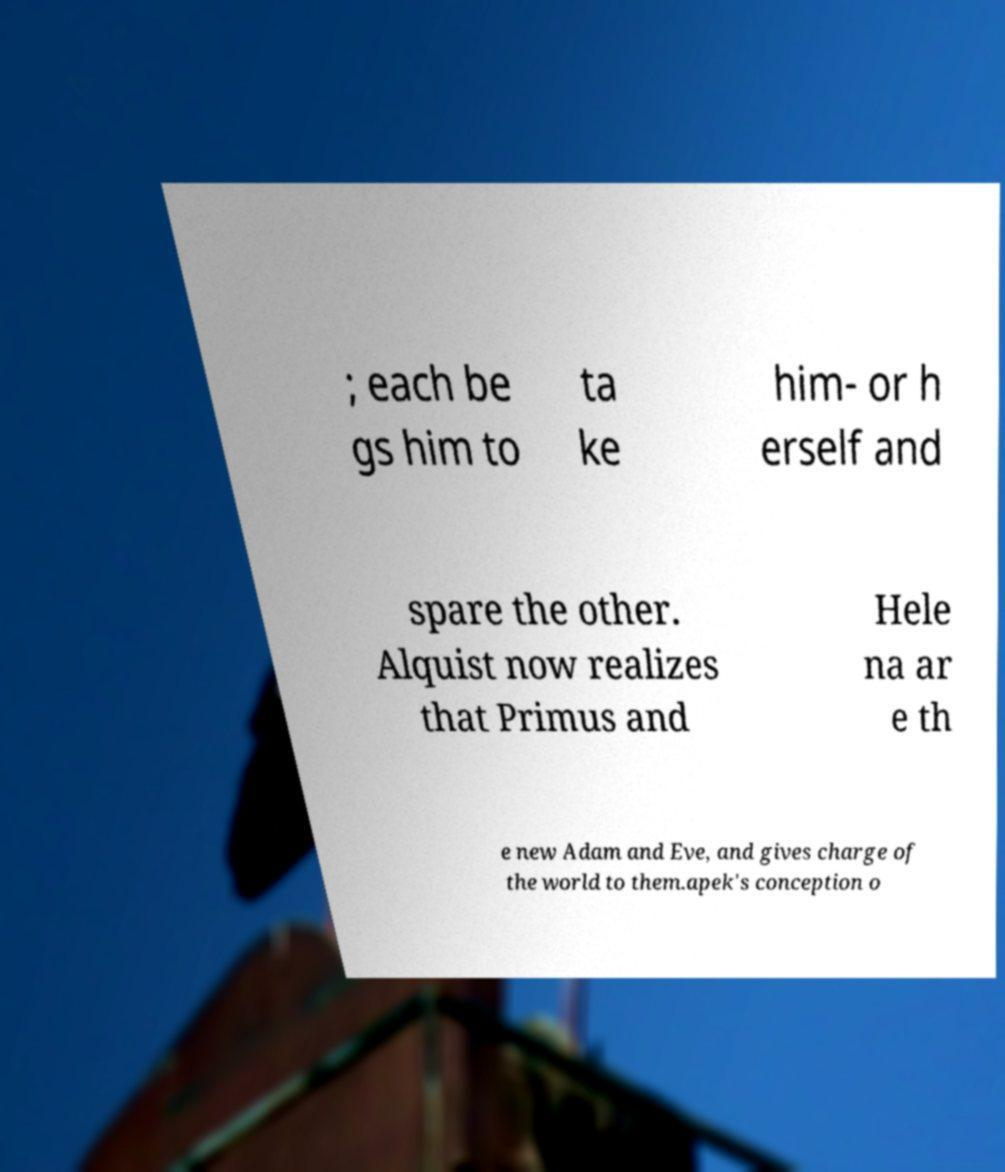Please identify and transcribe the text found in this image. ; each be gs him to ta ke him- or h erself and spare the other. Alquist now realizes that Primus and Hele na ar e th e new Adam and Eve, and gives charge of the world to them.apek's conception o 